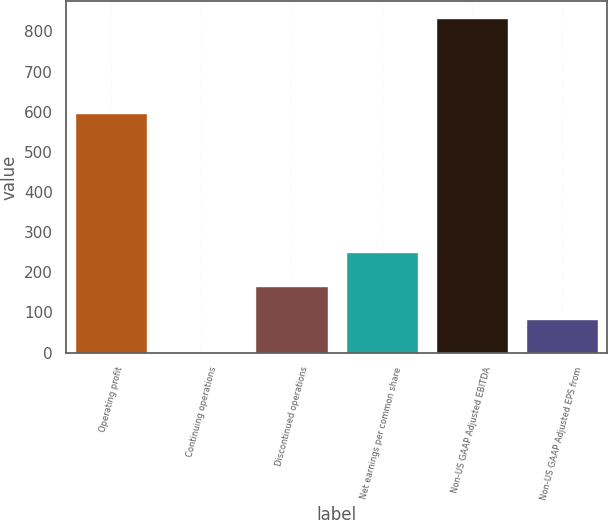<chart> <loc_0><loc_0><loc_500><loc_500><bar_chart><fcel>Operating profit<fcel>Continuing operations<fcel>Discontinued operations<fcel>Net earnings per common share<fcel>Non-US GAAP Adjusted EBITDA<fcel>Non-US GAAP Adjusted EPS from<nl><fcel>596<fcel>0.34<fcel>166.94<fcel>250.24<fcel>833.3<fcel>83.64<nl></chart> 